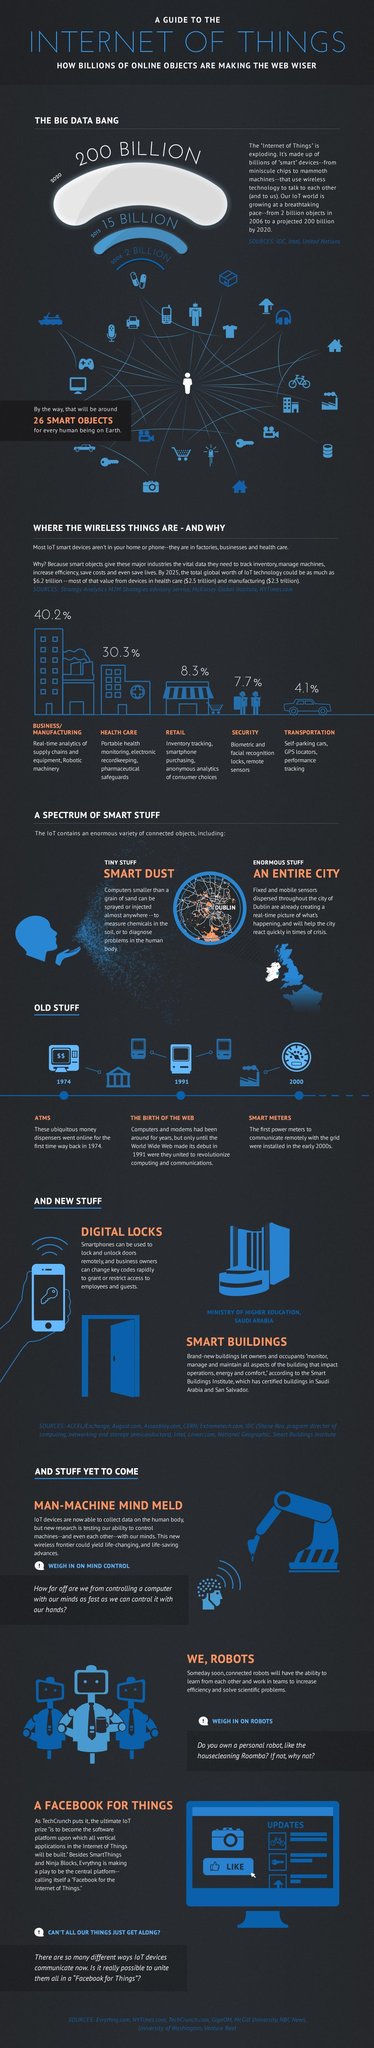Which industry uses IoT the most?
Answer the question with a short phrase. BUSINESS/MANUFACTURING What percent of IoT is used by retail? 8.3% 